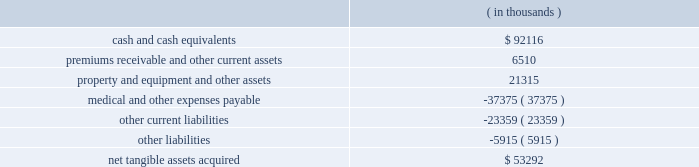Humana inc .
Notes to consolidated financial statements 2014 ( continued ) the grant-date fair value of the award will be estimated using option-pricing models .
In addition , certain tax effects of stock option exercises will be reported as a financing activity rather than an operating activity in the statements of cash flows .
We adopted sfas 123r on january 1 , 2006 under the retrospective transition method using the black-scholes pricing model .
The effect of expensing stock options under a fair value approach using the black-scholes pricing model on diluted earnings per common share for the years ended december 31 , 2005 , 2004 and 2003 is disclosed on page 69 .
In addition , the classification of cash inflows from any excess tax benefit associated with exercising stock options will change from an operating activity to a financing activity in the consolidated statements of cash flows with no impact on total cash flows .
We estimate the impact of this change in classification will decrease operating cash flows ( and increase financing cash flows ) by approximately $ 15.5 million in 2005 , $ 3.7 million in 2004 , and $ 15.2 million in 2003 .
Stock option expense after adopting sfas 123r is not expected to be materially different than our pro forma disclosure on page 69 and is dependent on levels of stock options granted during 2006 .
Acquisitions in january 2006 , our commercial segment reached an agreement to acquire cha service company , or cha health , a health plan serving employer groups in kentucky , for cash consideration of approximately $ 60.0 million plus any excess statutory surplus .
This transaction , which is subject to regulatory approval , is expected to close effective in the second quarter of 2006 .
On december 20 , 2005 , our commercial segment acquired corphealth , inc. , or corphealth , a behavioral health care management company , for cash consideration of approximately $ 54.2 million , including transaction costs .
This acquisition allows humana to integrate coverage of medical and behavior health benefits .
Net tangible assets acquired of $ 6.0 million primarily consisted of cash and cash equivalents .
The purchase price exceeded the estimated fair value of the net tangible assets acquired by approximately $ 48.2 million .
We preliminarily allocated this excess purchase price to other intangible assets of $ 8.6 million and associated deferred tax liabilities of $ 3.2 million , and non-deductible goodwill of $ 42.8 million .
The other intangible assets , which consist primarily of customer contracts , have a weighted average useful life of 14.7 years .
The allocation is subject to change pending completion of the valuation by a third party valuation specialist firm assisting us in evaluating the fair value of the assets acquired .
On february 16 , 2005 , our government segment acquired careplus health plans of florida , or careplus , as well as its affiliated 10 medical centers and pharmacy company .
Careplus provides medicare advantage hmo plans and benefits to medicare advantage members in miami-dade , broward and palm beach counties .
This acquisition enhances our medicare market position in south florida .
We paid approximately $ 444.9 million in cash , including transaction costs .
We financed the transaction with $ 294.0 million of borrowings under our credit agreement and $ 150.9 million of cash on hand .
The purchase price is subject to a balance sheet settlement process with a nine month claims run-out period .
This settlement , which will be reflected as an adjustment to goodwill , is not expected to be material .
The fair value of the acquired tangible assets ( assumed liabilities ) consisted of the following: .

What is the total value of assets , in thousands? 
Rationale: it is the sum of all assets .
Computations: ((6510 + 92116) + 21315)
Answer: 119941.0. Humana inc .
Notes to consolidated financial statements 2014 ( continued ) the grant-date fair value of the award will be estimated using option-pricing models .
In addition , certain tax effects of stock option exercises will be reported as a financing activity rather than an operating activity in the statements of cash flows .
We adopted sfas 123r on january 1 , 2006 under the retrospective transition method using the black-scholes pricing model .
The effect of expensing stock options under a fair value approach using the black-scholes pricing model on diluted earnings per common share for the years ended december 31 , 2005 , 2004 and 2003 is disclosed on page 69 .
In addition , the classification of cash inflows from any excess tax benefit associated with exercising stock options will change from an operating activity to a financing activity in the consolidated statements of cash flows with no impact on total cash flows .
We estimate the impact of this change in classification will decrease operating cash flows ( and increase financing cash flows ) by approximately $ 15.5 million in 2005 , $ 3.7 million in 2004 , and $ 15.2 million in 2003 .
Stock option expense after adopting sfas 123r is not expected to be materially different than our pro forma disclosure on page 69 and is dependent on levels of stock options granted during 2006 .
Acquisitions in january 2006 , our commercial segment reached an agreement to acquire cha service company , or cha health , a health plan serving employer groups in kentucky , for cash consideration of approximately $ 60.0 million plus any excess statutory surplus .
This transaction , which is subject to regulatory approval , is expected to close effective in the second quarter of 2006 .
On december 20 , 2005 , our commercial segment acquired corphealth , inc. , or corphealth , a behavioral health care management company , for cash consideration of approximately $ 54.2 million , including transaction costs .
This acquisition allows humana to integrate coverage of medical and behavior health benefits .
Net tangible assets acquired of $ 6.0 million primarily consisted of cash and cash equivalents .
The purchase price exceeded the estimated fair value of the net tangible assets acquired by approximately $ 48.2 million .
We preliminarily allocated this excess purchase price to other intangible assets of $ 8.6 million and associated deferred tax liabilities of $ 3.2 million , and non-deductible goodwill of $ 42.8 million .
The other intangible assets , which consist primarily of customer contracts , have a weighted average useful life of 14.7 years .
The allocation is subject to change pending completion of the valuation by a third party valuation specialist firm assisting us in evaluating the fair value of the assets acquired .
On february 16 , 2005 , our government segment acquired careplus health plans of florida , or careplus , as well as its affiliated 10 medical centers and pharmacy company .
Careplus provides medicare advantage hmo plans and benefits to medicare advantage members in miami-dade , broward and palm beach counties .
This acquisition enhances our medicare market position in south florida .
We paid approximately $ 444.9 million in cash , including transaction costs .
We financed the transaction with $ 294.0 million of borrowings under our credit agreement and $ 150.9 million of cash on hand .
The purchase price is subject to a balance sheet settlement process with a nine month claims run-out period .
This settlement , which will be reflected as an adjustment to goodwill , is not expected to be material .
The fair value of the acquired tangible assets ( assumed liabilities ) consisted of the following: .

On december 20 , 2005 what was the ratio of the cash and cash equivalents to the net tangible assets acquired? 
Computations: (92116 / 53292)
Answer: 1.72851. 